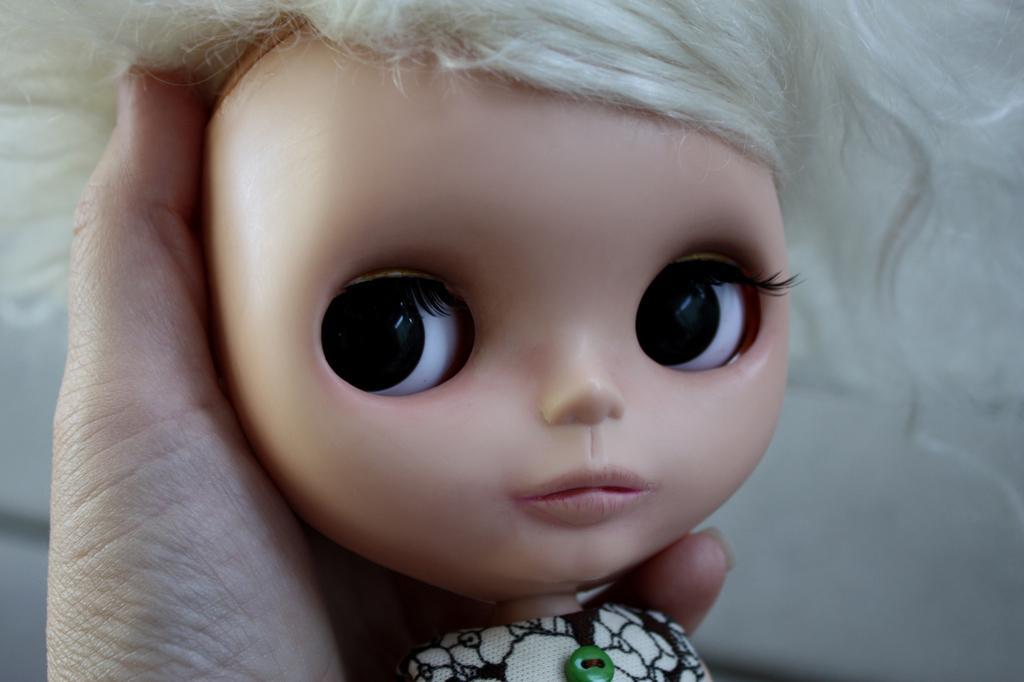In one or two sentences, can you explain what this image depicts? In the image we can see there is a doll in the hands of a person. 